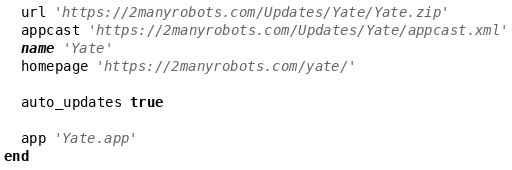<code> <loc_0><loc_0><loc_500><loc_500><_Ruby_>
  url 'https://2manyrobots.com/Updates/Yate/Yate.zip'
  appcast 'https://2manyrobots.com/Updates/Yate/appcast.xml'
  name 'Yate'
  homepage 'https://2manyrobots.com/yate/'

  auto_updates true

  app 'Yate.app'
end
</code> 